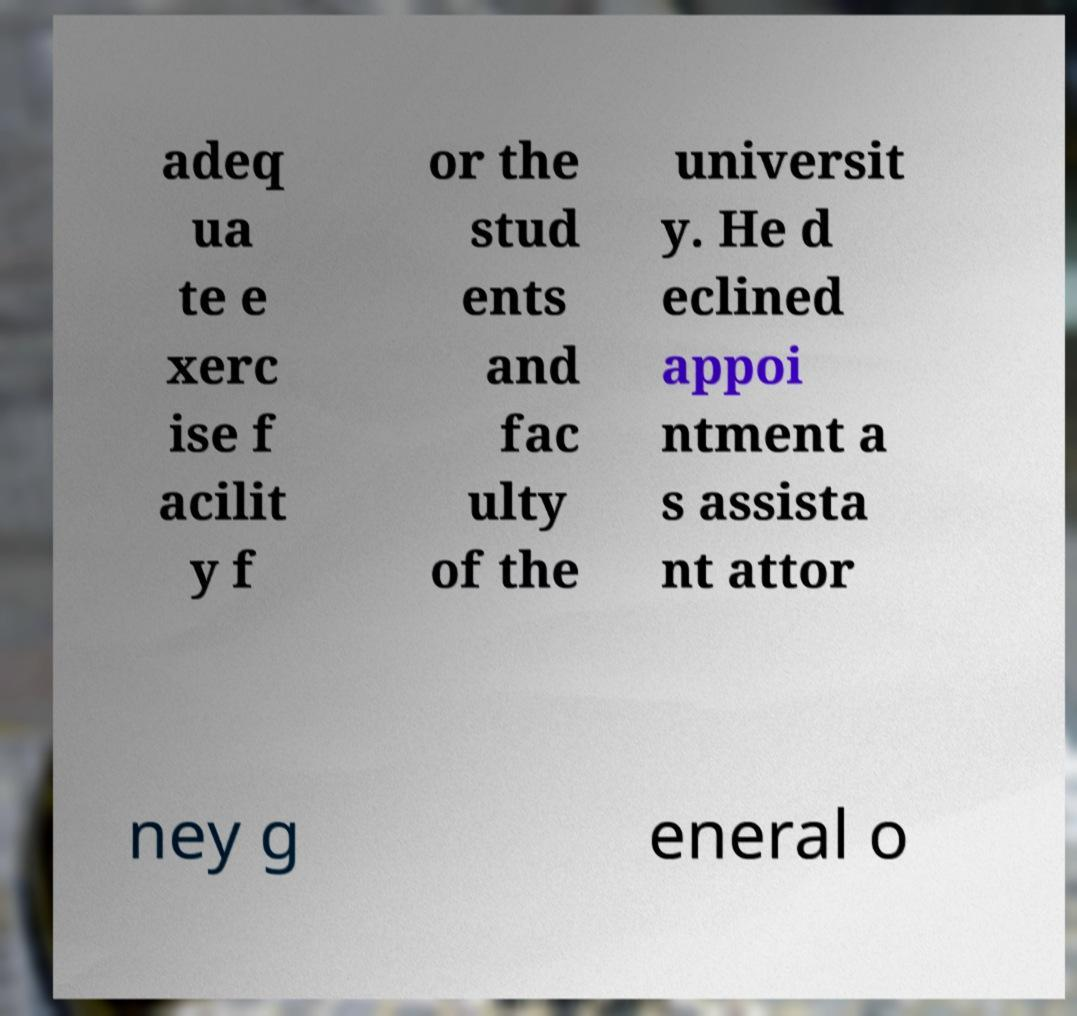What messages or text are displayed in this image? I need them in a readable, typed format. adeq ua te e xerc ise f acilit y f or the stud ents and fac ulty of the universit y. He d eclined appoi ntment a s assista nt attor ney g eneral o 